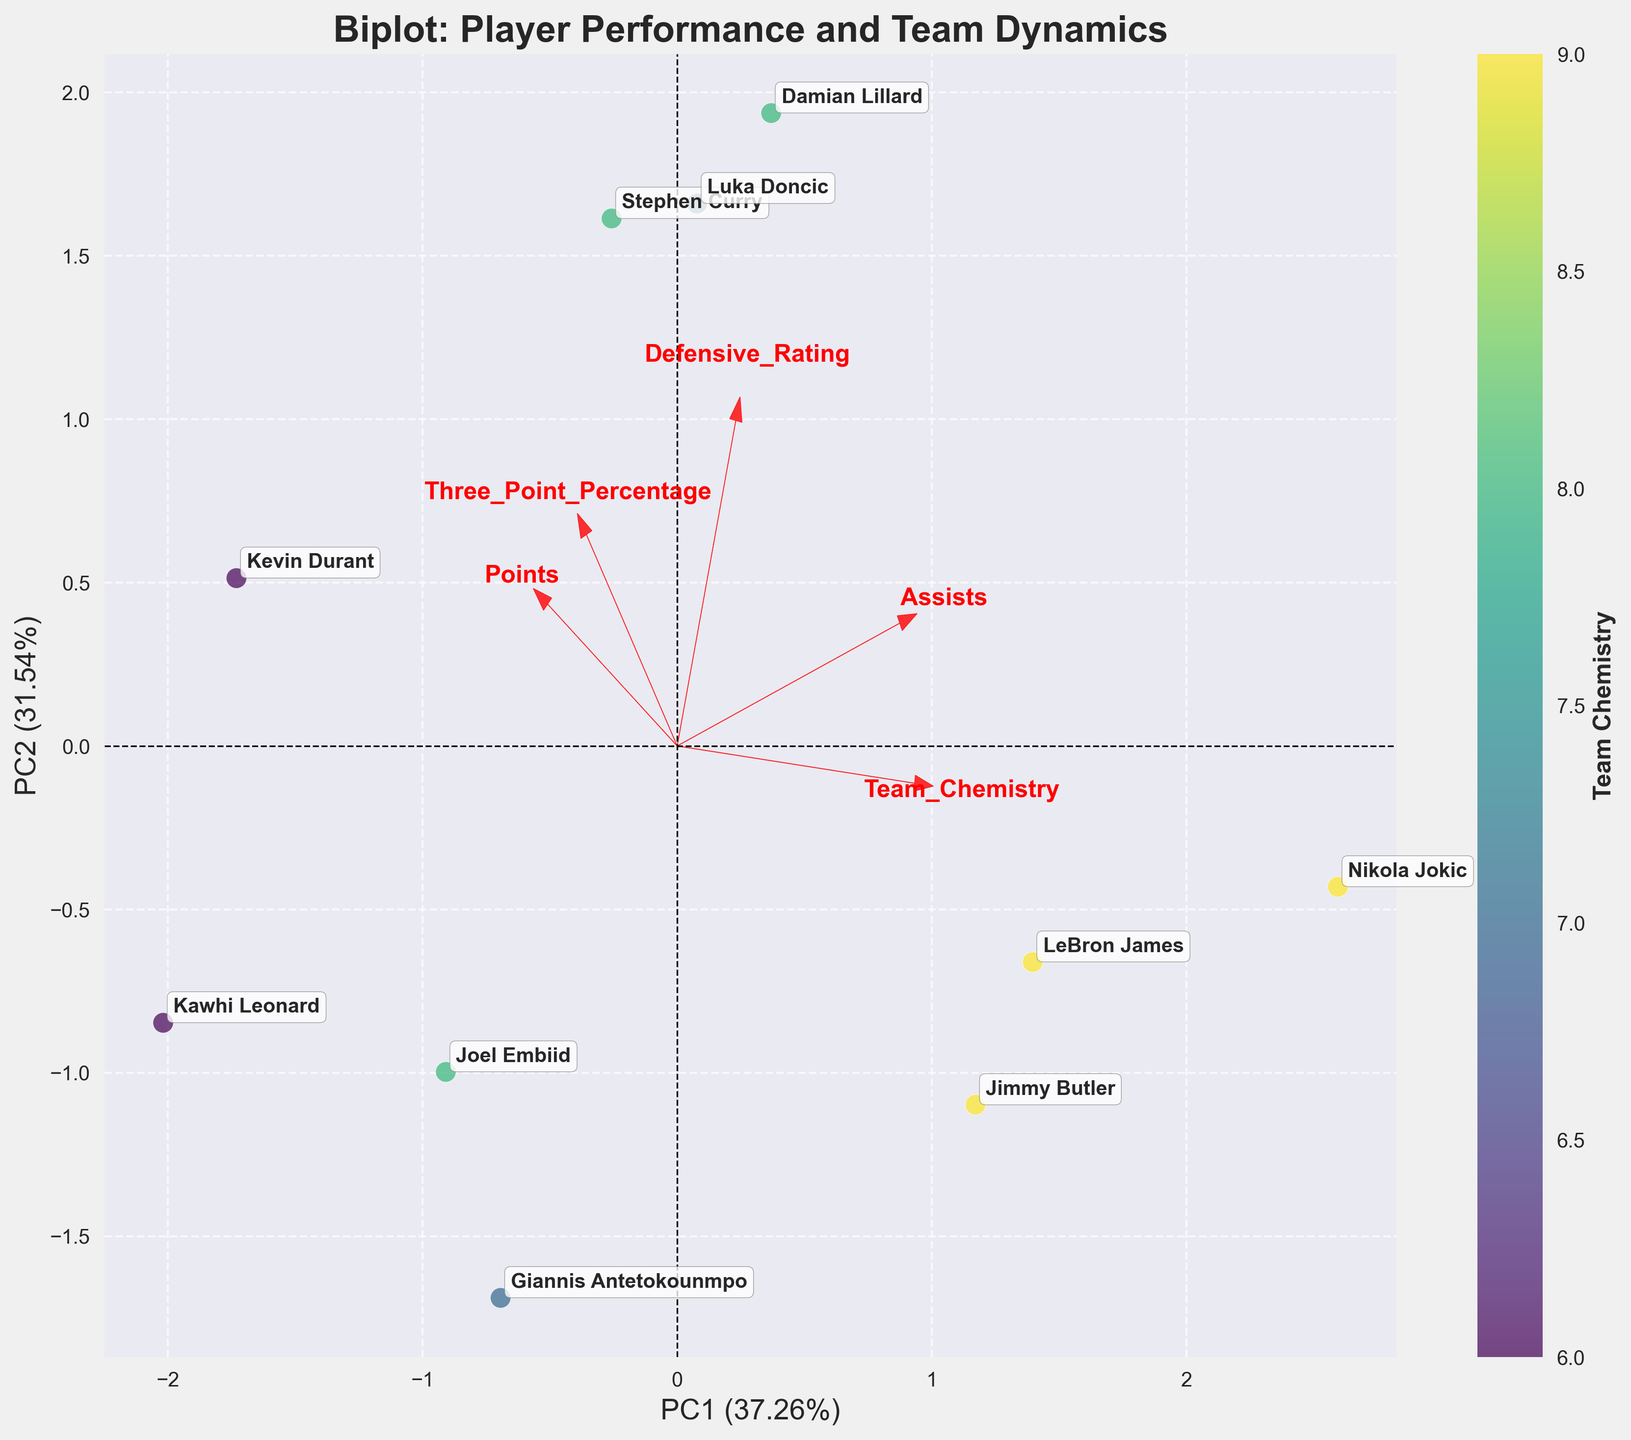How many players are shown in the biplot? Count the number of different player annotations visible in the plot. This number represents the players shown.
Answer: 10 What are the labels on the X and Y axes? Look at the titles of the X and Y axes labeled in the figure.
Answer: PC1, PC2 Which player has the highest Three Point Percentage according to the biplot? Examine the position of players in relation to the direction and length of the arrow labeled 'Three_Point_Percentage'. The player furthest in this direction has the highest percentage.
Answer: Stephen Curry Which player is closest to the origin (0,0) on the biplot? Identify the player whose position in the figure is nearest to the point where the X and Y axes intersect.
Answer: Jimmy Butler How does Defensive Rating appear to correlate with PC1 and PC2? Observe the position and direction of the arrow labeled 'Defensive_Rating' relative to the PC1 and PC2 axes. If the arrow is closely aligned with either axis, it indicates a strong correlation.
Answer: Correlates less positively with PC1, more negatively with PC2 Which players have high values of Team Chemistry in the biplot? Look at the color bar representing 'Team Chemistry'. The players associated with darker shades (higher values) have high team chemistry.
Answer: LeBron James, Nikola Jokic, Jimmy Butler Do players with higher assists tend to have higher team chemistry? Compare the direction and length of the arrows labeled 'Assists' and 'Team_Chemistry' in the biplot. If they're aligned closely, a positive trend is indicated.
Answer: Yes Who are the two players with the closest scores on PC1? Identify the players whose scores on the X-axis (PC1) are nearly overlapping.
Answer: Stephen Curry, Kevin Durant Which player has the highest positive score on PC2? Find the player furthest along the positive Y-axis in the biplot.
Answer: Damian Lillard What feature has the strongest loading on PC1? Check the length of the arrows and direction to see which feature arrow extends the furthest along the PC1 axis.
Answer: Assists 